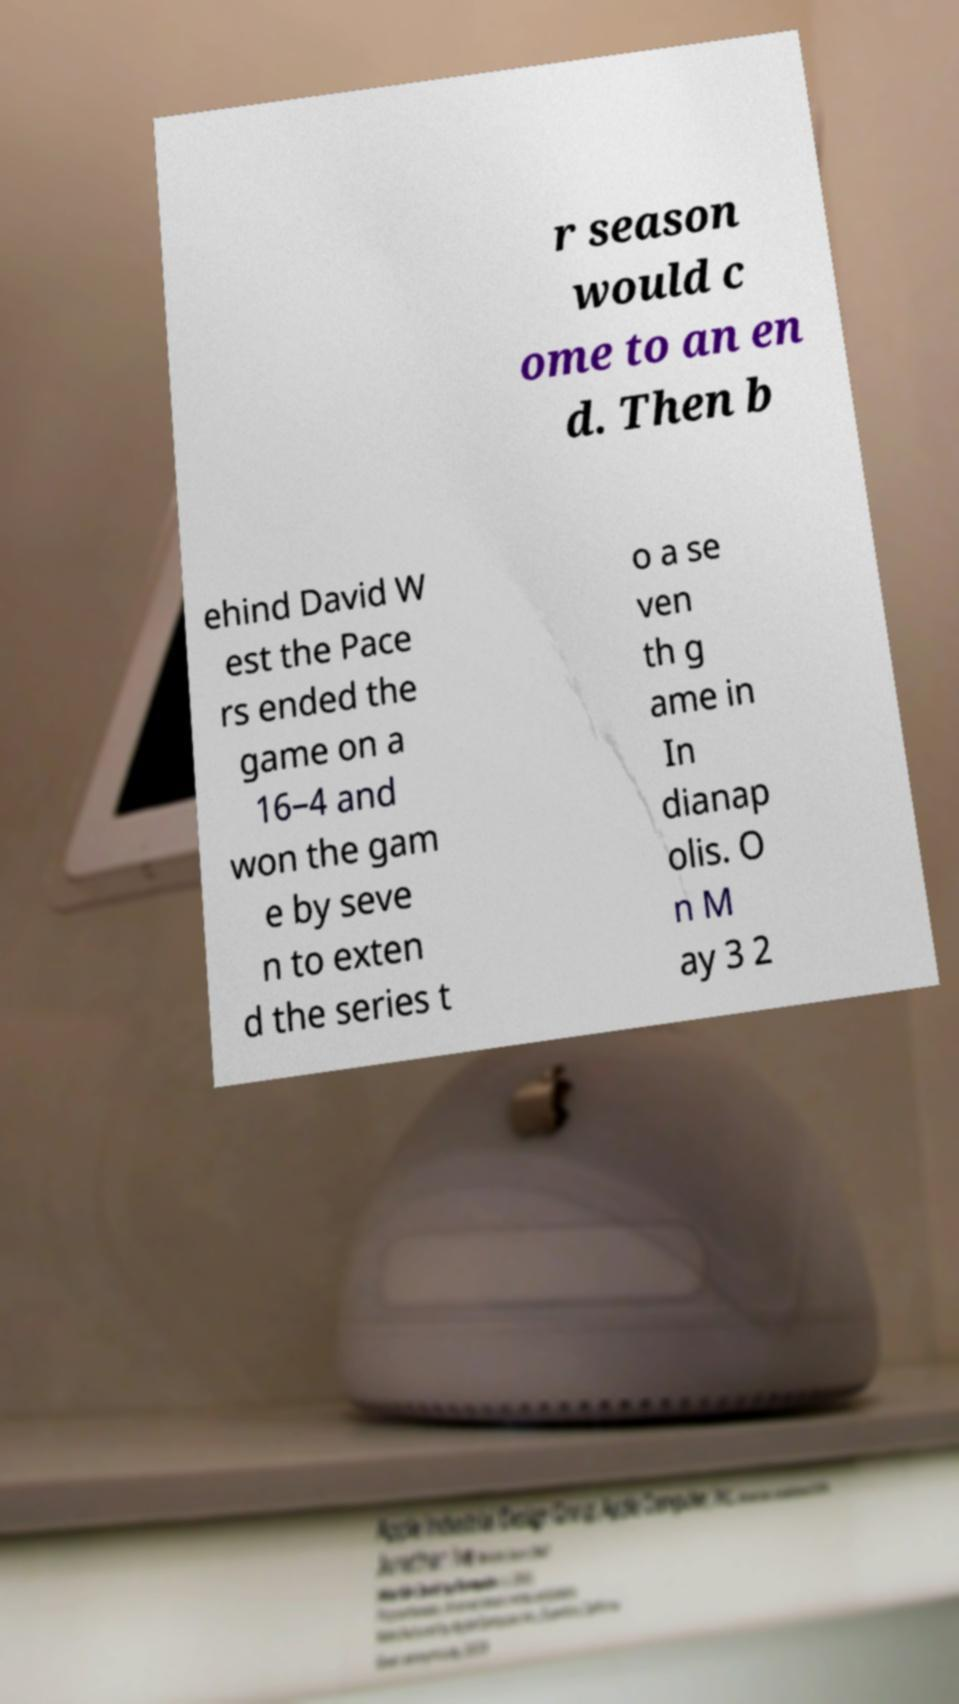Can you read and provide the text displayed in the image?This photo seems to have some interesting text. Can you extract and type it out for me? r season would c ome to an en d. Then b ehind David W est the Pace rs ended the game on a 16–4 and won the gam e by seve n to exten d the series t o a se ven th g ame in In dianap olis. O n M ay 3 2 